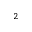Convert formula to latex. <formula><loc_0><loc_0><loc_500><loc_500>^ { 2 }</formula> 